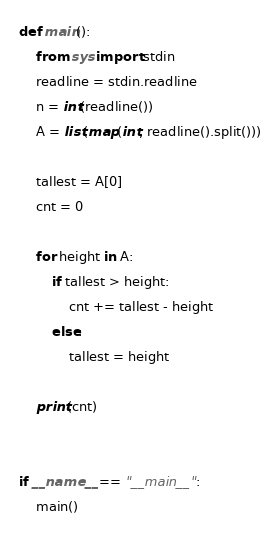<code> <loc_0><loc_0><loc_500><loc_500><_Python_>def main():
    from sys import stdin
    readline = stdin.readline
    n = int(readline())
    A = list(map(int, readline().split()))

    tallest = A[0]
    cnt = 0

    for height in A:
        if tallest > height:
            cnt += tallest - height
        else:
            tallest = height

    print(cnt)


if __name__ == "__main__":
    main()</code> 